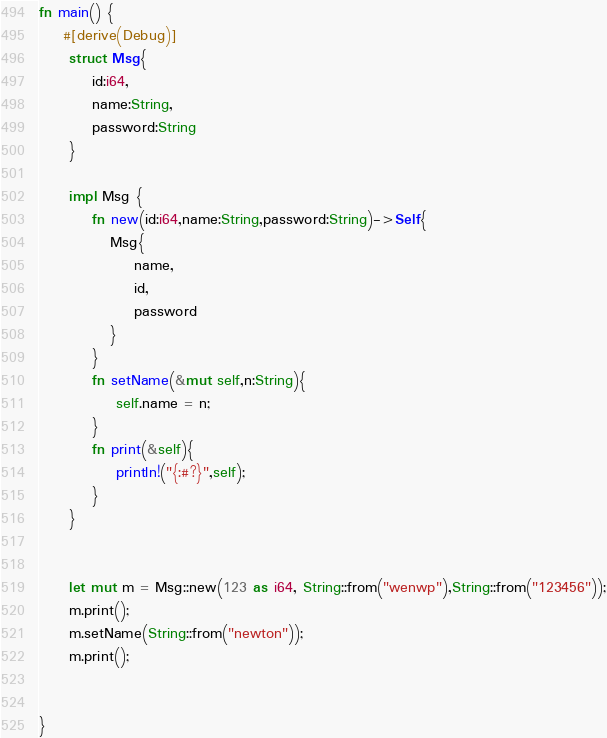<code> <loc_0><loc_0><loc_500><loc_500><_Rust_>

fn main() {
    #[derive(Debug)]
     struct Msg{
         id:i64,
         name:String,
         password:String
     }

     impl Msg {
         fn new(id:i64,name:String,password:String)->Self{
            Msg{
                name,
                id,
                password
            }
         }
         fn setName(&mut self,n:String){
             self.name = n;
         }
         fn print(&self){
             println!("{:#?}",self);
         }
     }

   
     let mut m = Msg::new(123 as i64, String::from("wenwp"),String::from("123456"));
     m.print();
     m.setName(String::from("newton"));
     m.print();
    

}
</code> 